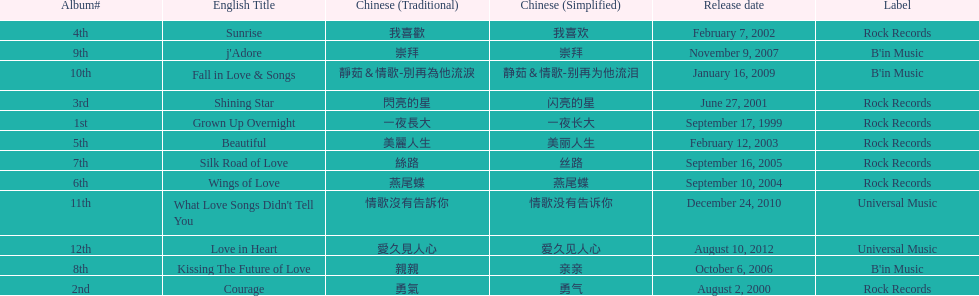Which was the only album to be released by b'in music in an even-numbered year? Kissing The Future of Love. 